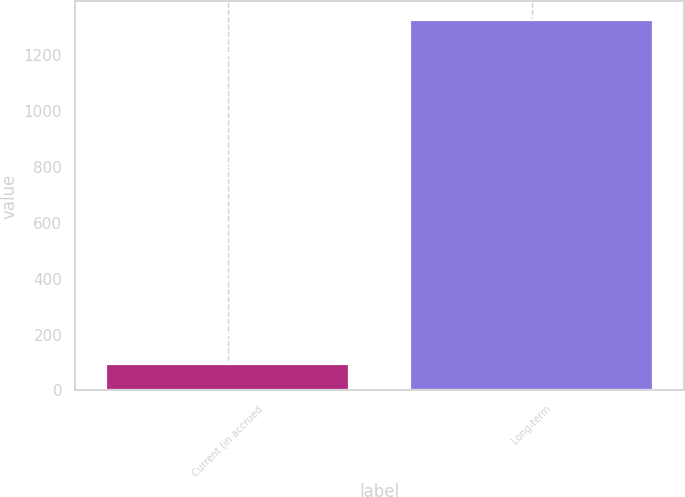Convert chart to OTSL. <chart><loc_0><loc_0><loc_500><loc_500><bar_chart><fcel>Current (in accrued<fcel>Long-term<nl><fcel>95<fcel>1326<nl></chart> 